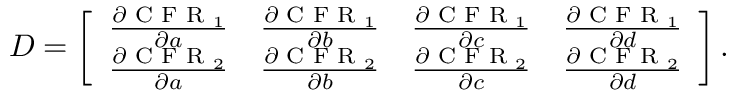Convert formula to latex. <formula><loc_0><loc_0><loc_500><loc_500>\begin{array} { r } { D = \left [ \begin{array} { l l l l } { \frac { \partial C F R _ { 1 } } { \partial a } } & { \frac { \partial C F R _ { 1 } } { \partial b } } & { \frac { \partial C F R _ { 1 } } { \partial c } } & { \frac { \partial C F R _ { 1 } } { \partial d } } \\ { \frac { \partial C F R _ { 2 } } { \partial a } } & { \frac { \partial C F R _ { 2 } } { \partial b } } & { \frac { \partial C F R _ { 2 } } { \partial c } } & { \frac { \partial C F R _ { 2 } } { \partial d } } \end{array} \right ] . } \end{array}</formula> 